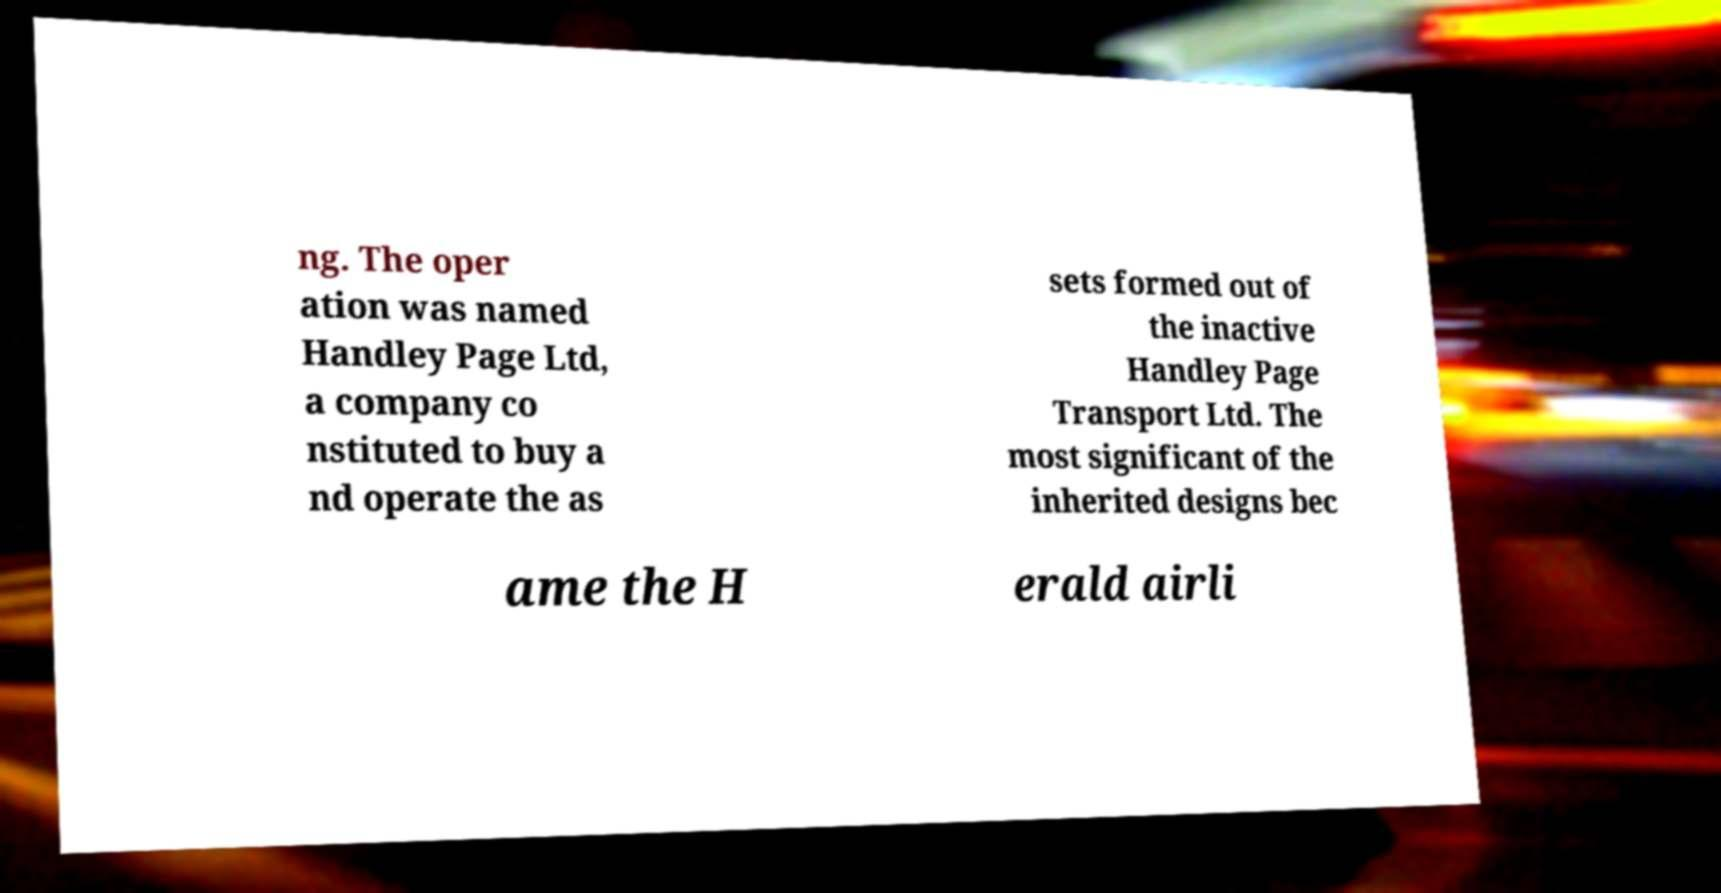Can you read and provide the text displayed in the image?This photo seems to have some interesting text. Can you extract and type it out for me? ng. The oper ation was named Handley Page Ltd, a company co nstituted to buy a nd operate the as sets formed out of the inactive Handley Page Transport Ltd. The most significant of the inherited designs bec ame the H erald airli 